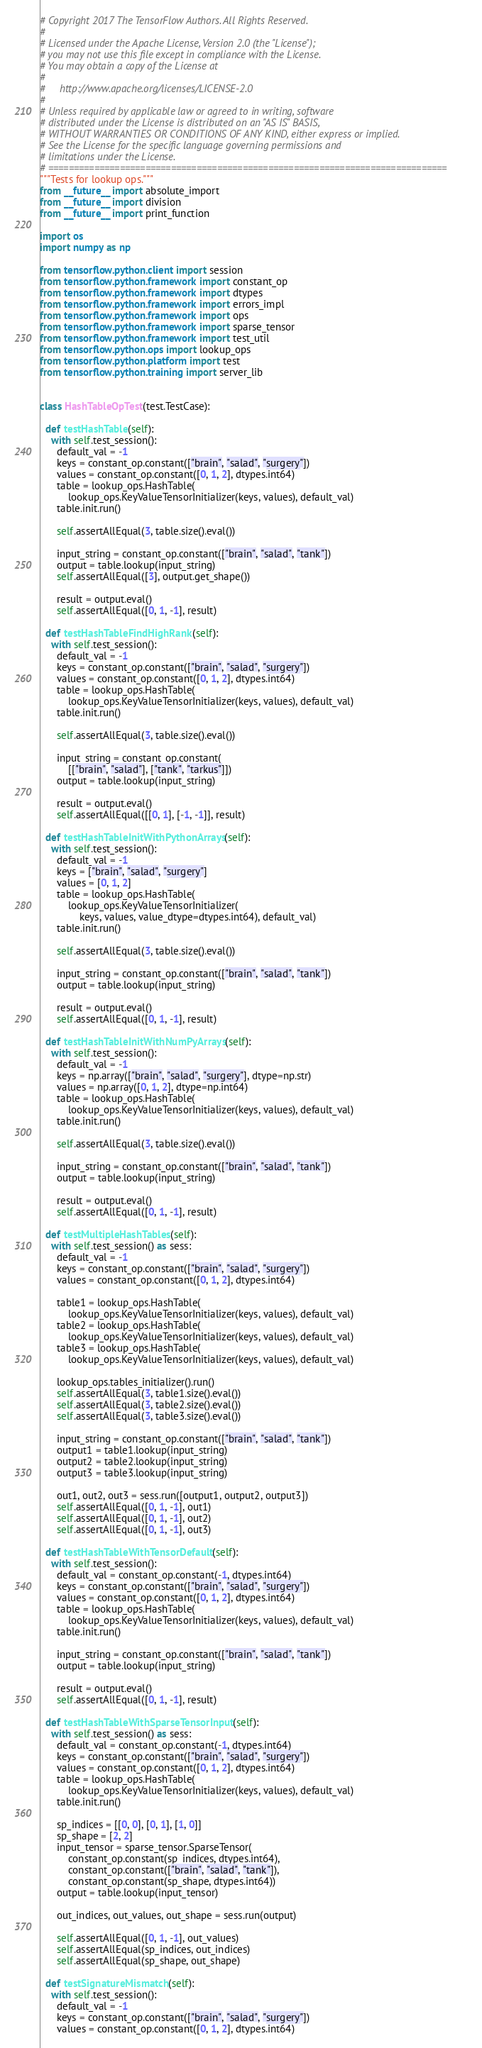Convert code to text. <code><loc_0><loc_0><loc_500><loc_500><_Python_># Copyright 2017 The TensorFlow Authors. All Rights Reserved.
#
# Licensed under the Apache License, Version 2.0 (the "License");
# you may not use this file except in compliance with the License.
# You may obtain a copy of the License at
#
#     http://www.apache.org/licenses/LICENSE-2.0
#
# Unless required by applicable law or agreed to in writing, software
# distributed under the License is distributed on an "AS IS" BASIS,
# WITHOUT WARRANTIES OR CONDITIONS OF ANY KIND, either express or implied.
# See the License for the specific language governing permissions and
# limitations under the License.
# ==============================================================================
"""Tests for lookup ops."""
from __future__ import absolute_import
from __future__ import division
from __future__ import print_function

import os
import numpy as np

from tensorflow.python.client import session
from tensorflow.python.framework import constant_op
from tensorflow.python.framework import dtypes
from tensorflow.python.framework import errors_impl
from tensorflow.python.framework import ops
from tensorflow.python.framework import sparse_tensor
from tensorflow.python.framework import test_util
from tensorflow.python.ops import lookup_ops
from tensorflow.python.platform import test
from tensorflow.python.training import server_lib


class HashTableOpTest(test.TestCase):

  def testHashTable(self):
    with self.test_session():
      default_val = -1
      keys = constant_op.constant(["brain", "salad", "surgery"])
      values = constant_op.constant([0, 1, 2], dtypes.int64)
      table = lookup_ops.HashTable(
          lookup_ops.KeyValueTensorInitializer(keys, values), default_val)
      table.init.run()

      self.assertAllEqual(3, table.size().eval())

      input_string = constant_op.constant(["brain", "salad", "tank"])
      output = table.lookup(input_string)
      self.assertAllEqual([3], output.get_shape())

      result = output.eval()
      self.assertAllEqual([0, 1, -1], result)

  def testHashTableFindHighRank(self):
    with self.test_session():
      default_val = -1
      keys = constant_op.constant(["brain", "salad", "surgery"])
      values = constant_op.constant([0, 1, 2], dtypes.int64)
      table = lookup_ops.HashTable(
          lookup_ops.KeyValueTensorInitializer(keys, values), default_val)
      table.init.run()

      self.assertAllEqual(3, table.size().eval())

      input_string = constant_op.constant(
          [["brain", "salad"], ["tank", "tarkus"]])
      output = table.lookup(input_string)

      result = output.eval()
      self.assertAllEqual([[0, 1], [-1, -1]], result)

  def testHashTableInitWithPythonArrays(self):
    with self.test_session():
      default_val = -1
      keys = ["brain", "salad", "surgery"]
      values = [0, 1, 2]
      table = lookup_ops.HashTable(
          lookup_ops.KeyValueTensorInitializer(
              keys, values, value_dtype=dtypes.int64), default_val)
      table.init.run()

      self.assertAllEqual(3, table.size().eval())

      input_string = constant_op.constant(["brain", "salad", "tank"])
      output = table.lookup(input_string)

      result = output.eval()
      self.assertAllEqual([0, 1, -1], result)

  def testHashTableInitWithNumPyArrays(self):
    with self.test_session():
      default_val = -1
      keys = np.array(["brain", "salad", "surgery"], dtype=np.str)
      values = np.array([0, 1, 2], dtype=np.int64)
      table = lookup_ops.HashTable(
          lookup_ops.KeyValueTensorInitializer(keys, values), default_val)
      table.init.run()

      self.assertAllEqual(3, table.size().eval())

      input_string = constant_op.constant(["brain", "salad", "tank"])
      output = table.lookup(input_string)

      result = output.eval()
      self.assertAllEqual([0, 1, -1], result)

  def testMultipleHashTables(self):
    with self.test_session() as sess:
      default_val = -1
      keys = constant_op.constant(["brain", "salad", "surgery"])
      values = constant_op.constant([0, 1, 2], dtypes.int64)

      table1 = lookup_ops.HashTable(
          lookup_ops.KeyValueTensorInitializer(keys, values), default_val)
      table2 = lookup_ops.HashTable(
          lookup_ops.KeyValueTensorInitializer(keys, values), default_val)
      table3 = lookup_ops.HashTable(
          lookup_ops.KeyValueTensorInitializer(keys, values), default_val)

      lookup_ops.tables_initializer().run()
      self.assertAllEqual(3, table1.size().eval())
      self.assertAllEqual(3, table2.size().eval())
      self.assertAllEqual(3, table3.size().eval())

      input_string = constant_op.constant(["brain", "salad", "tank"])
      output1 = table1.lookup(input_string)
      output2 = table2.lookup(input_string)
      output3 = table3.lookup(input_string)

      out1, out2, out3 = sess.run([output1, output2, output3])
      self.assertAllEqual([0, 1, -1], out1)
      self.assertAllEqual([0, 1, -1], out2)
      self.assertAllEqual([0, 1, -1], out3)

  def testHashTableWithTensorDefault(self):
    with self.test_session():
      default_val = constant_op.constant(-1, dtypes.int64)
      keys = constant_op.constant(["brain", "salad", "surgery"])
      values = constant_op.constant([0, 1, 2], dtypes.int64)
      table = lookup_ops.HashTable(
          lookup_ops.KeyValueTensorInitializer(keys, values), default_val)
      table.init.run()

      input_string = constant_op.constant(["brain", "salad", "tank"])
      output = table.lookup(input_string)

      result = output.eval()
      self.assertAllEqual([0, 1, -1], result)

  def testHashTableWithSparseTensorInput(self):
    with self.test_session() as sess:
      default_val = constant_op.constant(-1, dtypes.int64)
      keys = constant_op.constant(["brain", "salad", "surgery"])
      values = constant_op.constant([0, 1, 2], dtypes.int64)
      table = lookup_ops.HashTable(
          lookup_ops.KeyValueTensorInitializer(keys, values), default_val)
      table.init.run()

      sp_indices = [[0, 0], [0, 1], [1, 0]]
      sp_shape = [2, 2]
      input_tensor = sparse_tensor.SparseTensor(
          constant_op.constant(sp_indices, dtypes.int64),
          constant_op.constant(["brain", "salad", "tank"]),
          constant_op.constant(sp_shape, dtypes.int64))
      output = table.lookup(input_tensor)

      out_indices, out_values, out_shape = sess.run(output)

      self.assertAllEqual([0, 1, -1], out_values)
      self.assertAllEqual(sp_indices, out_indices)
      self.assertAllEqual(sp_shape, out_shape)

  def testSignatureMismatch(self):
    with self.test_session():
      default_val = -1
      keys = constant_op.constant(["brain", "salad", "surgery"])
      values = constant_op.constant([0, 1, 2], dtypes.int64)</code> 